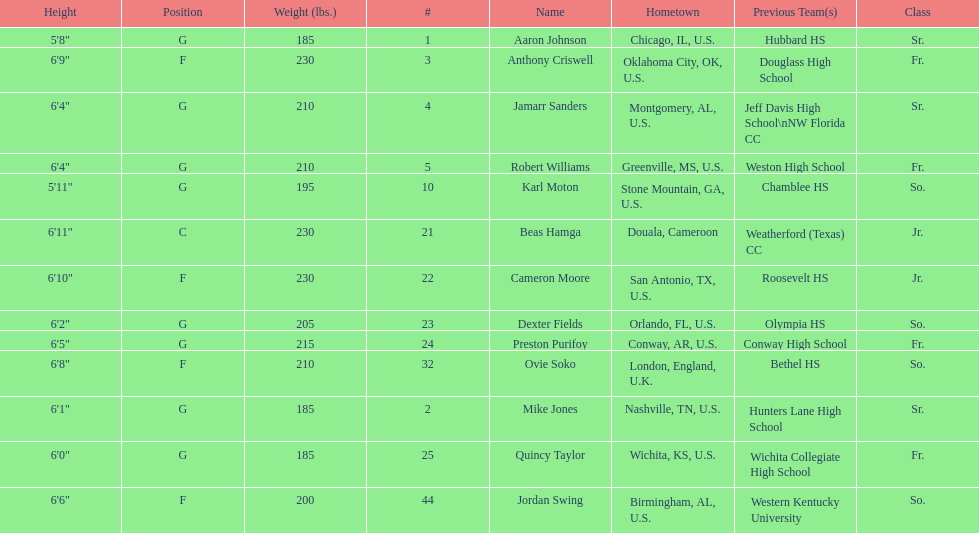How many players come from alabama? 2. Would you be able to parse every entry in this table? {'header': ['Height', 'Position', 'Weight (lbs.)', '#', 'Name', 'Hometown', 'Previous Team(s)', 'Class'], 'rows': [['5\'8"', 'G', '185', '1', 'Aaron Johnson', 'Chicago, IL, U.S.', 'Hubbard HS', 'Sr.'], ['6\'9"', 'F', '230', '3', 'Anthony Criswell', 'Oklahoma City, OK, U.S.', 'Douglass High School', 'Fr.'], ['6\'4"', 'G', '210', '4', 'Jamarr Sanders', 'Montgomery, AL, U.S.', 'Jeff Davis High School\\nNW Florida CC', 'Sr.'], ['6\'4"', 'G', '210', '5', 'Robert Williams', 'Greenville, MS, U.S.', 'Weston High School', 'Fr.'], ['5\'11"', 'G', '195', '10', 'Karl Moton', 'Stone Mountain, GA, U.S.', 'Chamblee HS', 'So.'], ['6\'11"', 'C', '230', '21', 'Beas Hamga', 'Douala, Cameroon', 'Weatherford (Texas) CC', 'Jr.'], ['6\'10"', 'F', '230', '22', 'Cameron Moore', 'San Antonio, TX, U.S.', 'Roosevelt HS', 'Jr.'], ['6\'2"', 'G', '205', '23', 'Dexter Fields', 'Orlando, FL, U.S.', 'Olympia HS', 'So.'], ['6\'5"', 'G', '215', '24', 'Preston Purifoy', 'Conway, AR, U.S.', 'Conway High School', 'Fr.'], ['6\'8"', 'F', '210', '32', 'Ovie Soko', 'London, England, U.K.', 'Bethel HS', 'So.'], ['6\'1"', 'G', '185', '2', 'Mike Jones', 'Nashville, TN, U.S.', 'Hunters Lane High School', 'Sr.'], ['6\'0"', 'G', '185', '25', 'Quincy Taylor', 'Wichita, KS, U.S.', 'Wichita Collegiate High School', 'Fr.'], ['6\'6"', 'F', '200', '44', 'Jordan Swing', 'Birmingham, AL, U.S.', 'Western Kentucky University', 'So.']]} 